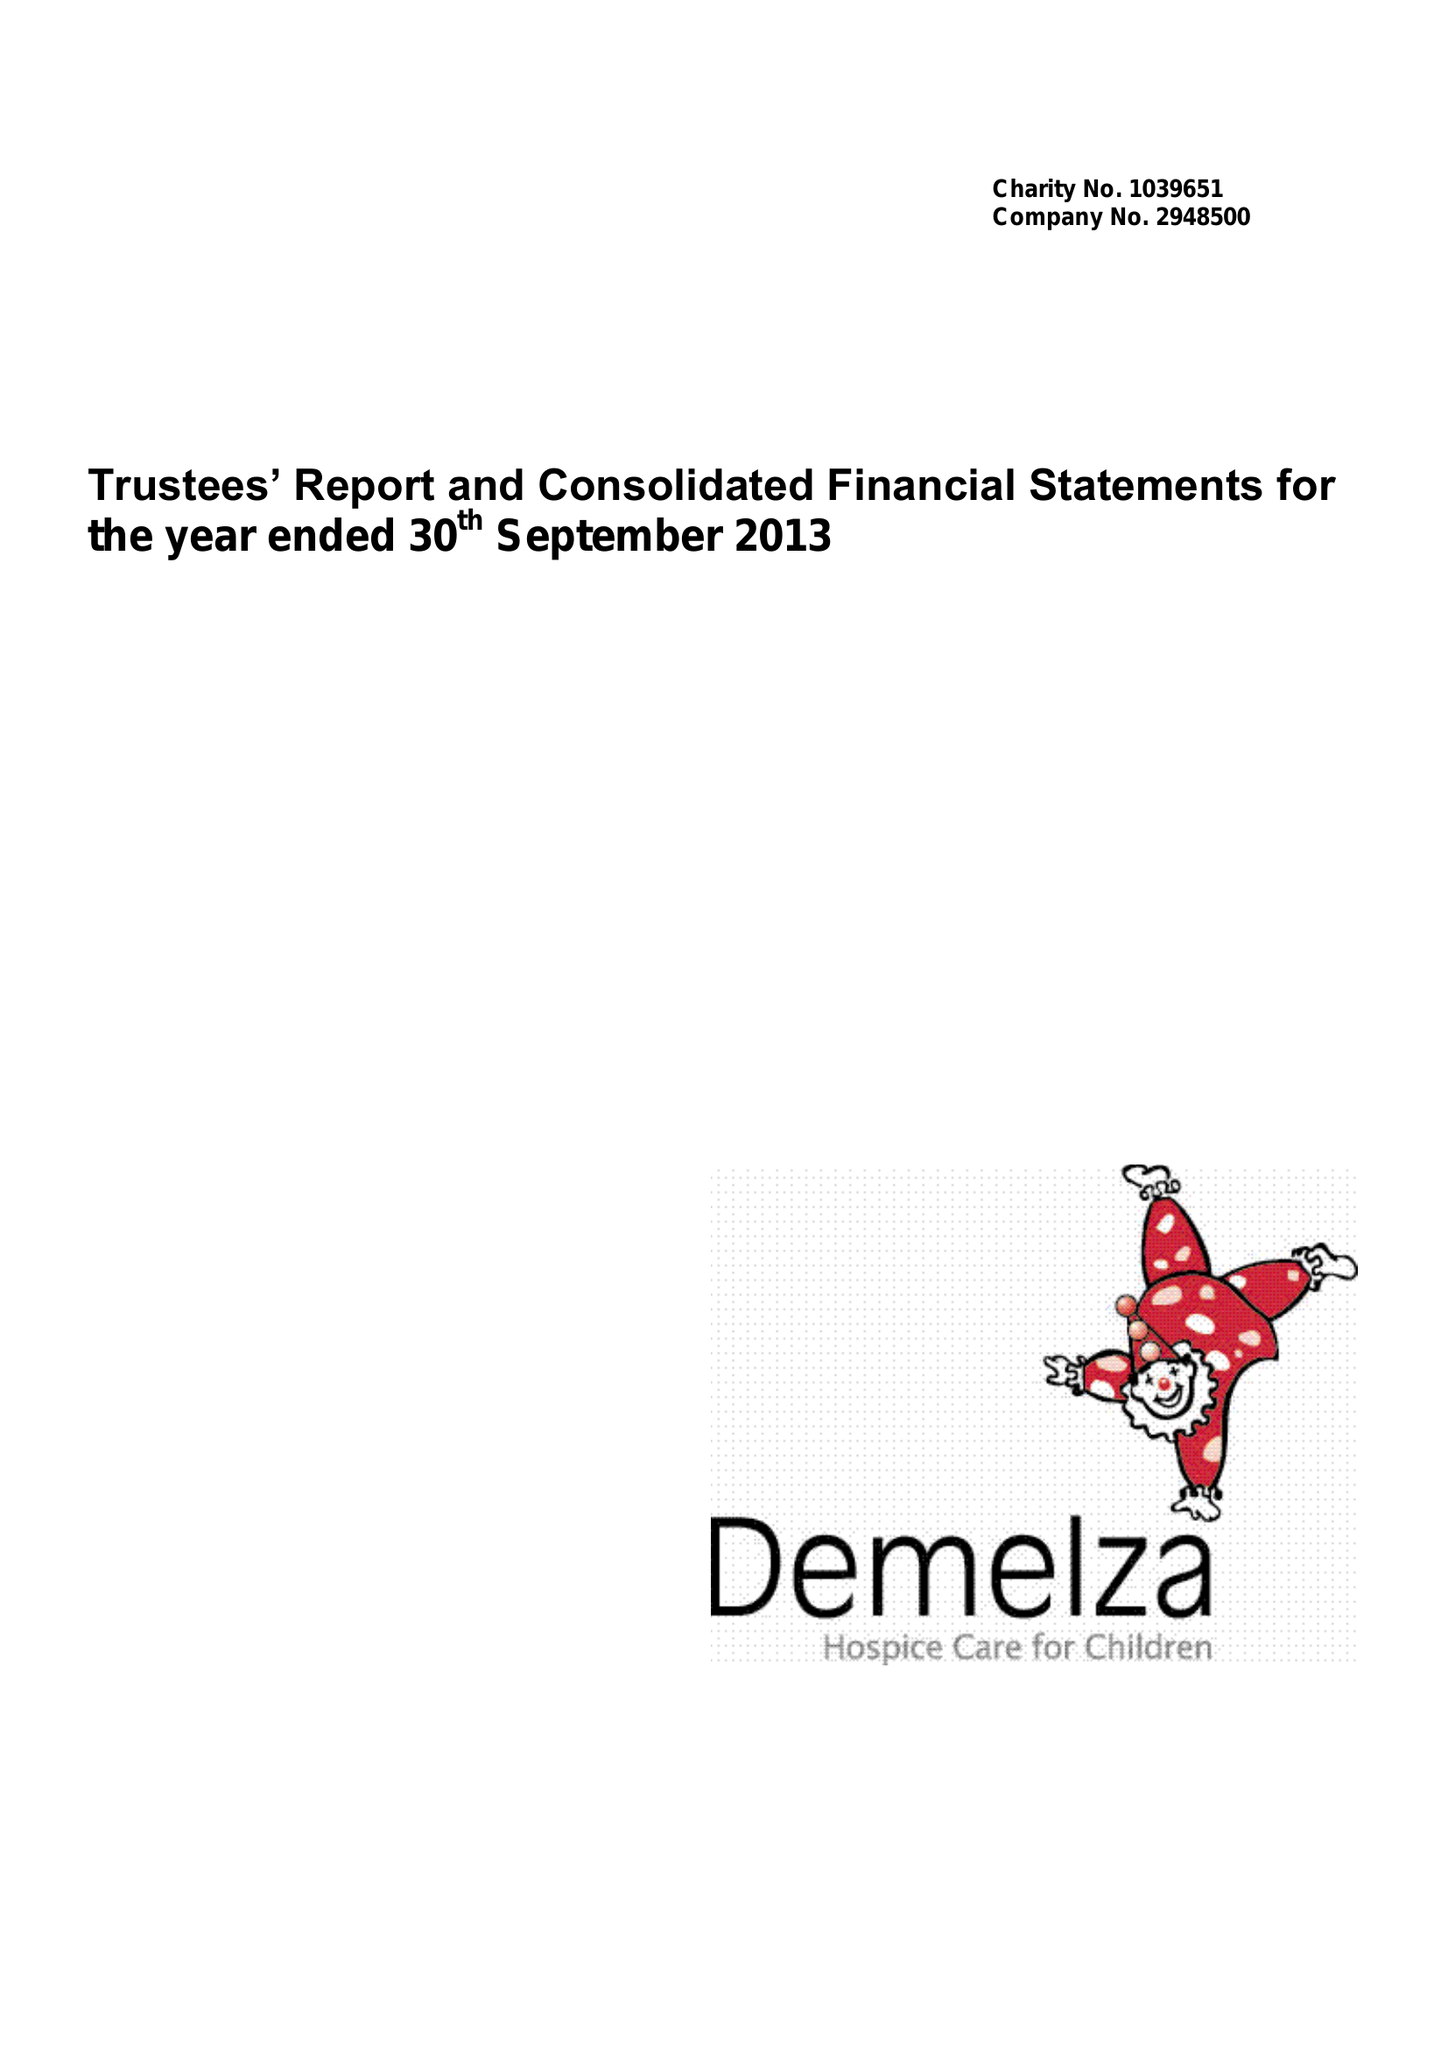What is the value for the spending_annually_in_british_pounds?
Answer the question using a single word or phrase. 9245931.00 